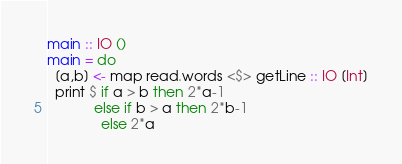Convert code to text. <code><loc_0><loc_0><loc_500><loc_500><_Haskell_>main :: IO ()
main = do
  [a,b] <- map read.words <$> getLine :: IO [Int]
  print $ if a > b then 2*a-1 
            else if b > a then 2*b-1
              else 2*a
</code> 